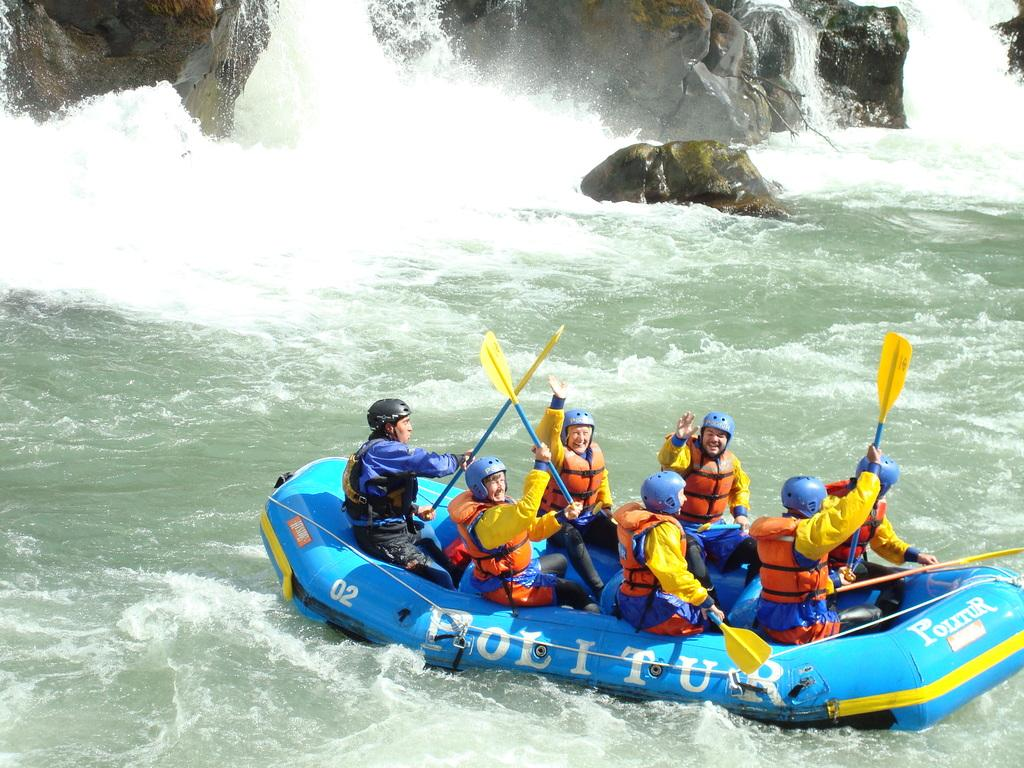What are the people in the image doing? The people in the image are sitting on a boat. What are some of the people holding? Some of the people are holding objects. What can be seen in the background of the image? There are rocks visible in the image. What is the primary element surrounding the boat? There is water visible in the image. Reasoning: Leting: Let's think step by step in order to produce the conversation. We start by identifying the main activity in the image, which is people sitting on a boat. Then, we expand the conversation to include other details, such as the objects being held by some of the people, the rocks in the background, and the water surrounding the boat. Each question is designed to elicit a specific detail about the image that is known from the provided facts. Absurd Question/Answer: Can you see an owl with a wing in the image? There is no owl or wing present in the image. Is there an office visible in the image? There is no office present in the image. 